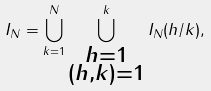<formula> <loc_0><loc_0><loc_500><loc_500>I _ { N } = \bigcup _ { k = 1 } ^ { N } \bigcup _ { \substack { h = 1 \\ ( h , k ) = 1 } } ^ { k } I _ { N } ( h / k ) ,</formula> 